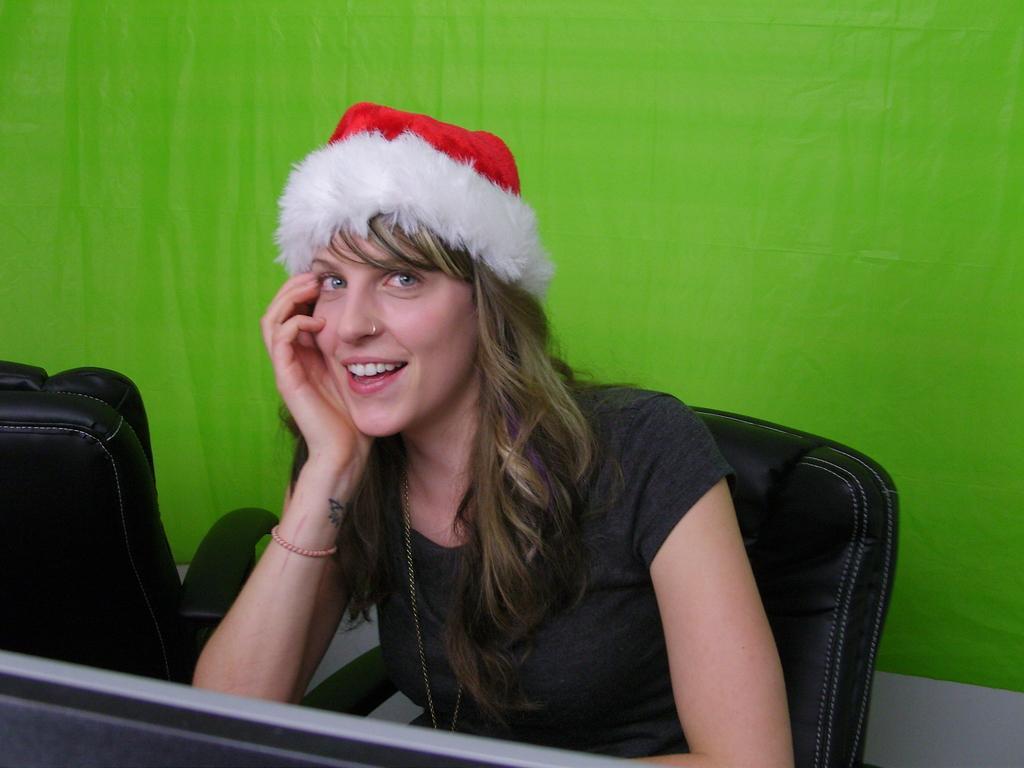How would you summarize this image in a sentence or two? In this image we can see a girl is sitting on a black chair and wearing black t-shirt with Christmas cap. Background of the image green and white color wall is there. Left side of the image one more black color chair is present. 